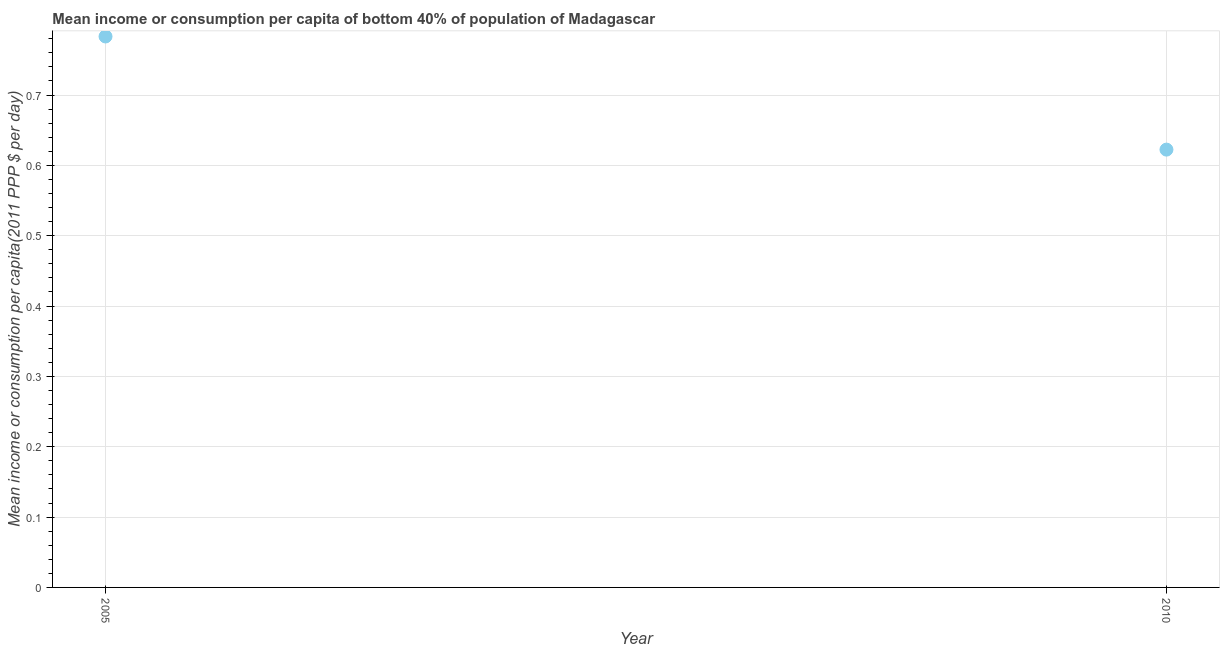What is the mean income or consumption in 2005?
Make the answer very short. 0.78. Across all years, what is the maximum mean income or consumption?
Your answer should be compact. 0.78. Across all years, what is the minimum mean income or consumption?
Offer a terse response. 0.62. In which year was the mean income or consumption maximum?
Make the answer very short. 2005. In which year was the mean income or consumption minimum?
Your answer should be compact. 2010. What is the sum of the mean income or consumption?
Offer a very short reply. 1.41. What is the difference between the mean income or consumption in 2005 and 2010?
Offer a terse response. 0.16. What is the average mean income or consumption per year?
Your answer should be compact. 0.7. What is the median mean income or consumption?
Ensure brevity in your answer.  0.7. What is the ratio of the mean income or consumption in 2005 to that in 2010?
Offer a terse response. 1.26. In how many years, is the mean income or consumption greater than the average mean income or consumption taken over all years?
Give a very brief answer. 1. Does the mean income or consumption monotonically increase over the years?
Give a very brief answer. No. How many years are there in the graph?
Your answer should be compact. 2. What is the difference between two consecutive major ticks on the Y-axis?
Ensure brevity in your answer.  0.1. Does the graph contain grids?
Provide a succinct answer. Yes. What is the title of the graph?
Give a very brief answer. Mean income or consumption per capita of bottom 40% of population of Madagascar. What is the label or title of the Y-axis?
Offer a terse response. Mean income or consumption per capita(2011 PPP $ per day). What is the Mean income or consumption per capita(2011 PPP $ per day) in 2005?
Offer a very short reply. 0.78. What is the Mean income or consumption per capita(2011 PPP $ per day) in 2010?
Keep it short and to the point. 0.62. What is the difference between the Mean income or consumption per capita(2011 PPP $ per day) in 2005 and 2010?
Ensure brevity in your answer.  0.16. What is the ratio of the Mean income or consumption per capita(2011 PPP $ per day) in 2005 to that in 2010?
Keep it short and to the point. 1.26. 